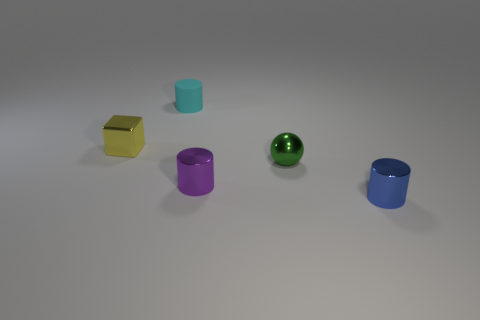Subtract all purple spheres. Subtract all purple blocks. How many spheres are left? 1 Add 1 small gray matte cylinders. How many objects exist? 6 Subtract all cylinders. How many objects are left? 2 Add 2 small cyan things. How many small cyan things are left? 3 Add 1 metallic things. How many metallic things exist? 5 Subtract 0 green blocks. How many objects are left? 5 Subtract all green metallic spheres. Subtract all small purple balls. How many objects are left? 4 